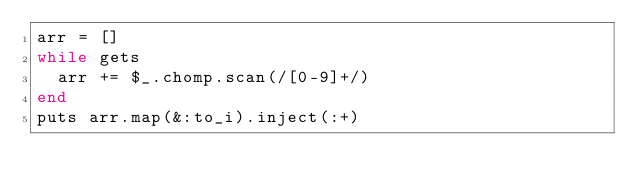<code> <loc_0><loc_0><loc_500><loc_500><_Ruby_>arr = []
while gets
  arr += $_.chomp.scan(/[0-9]+/)
end
puts arr.map(&:to_i).inject(:+)</code> 